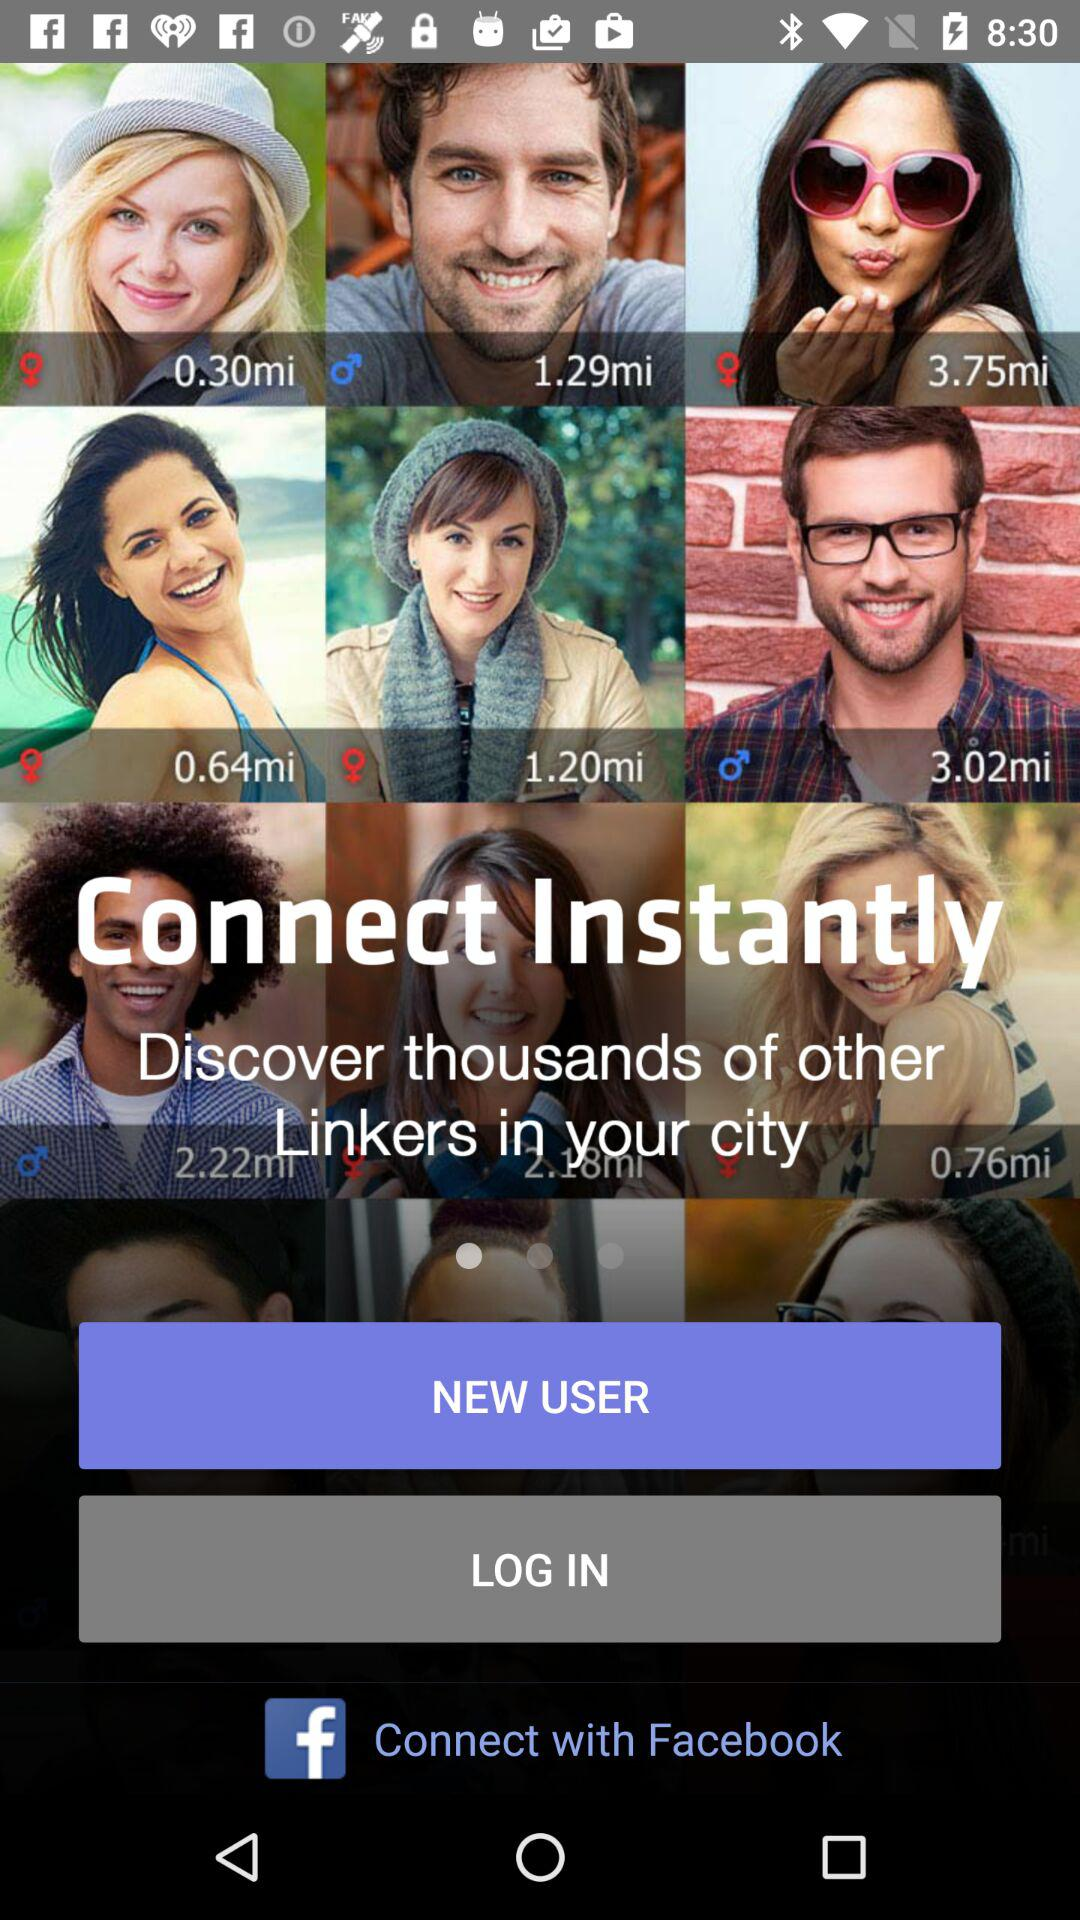What applications can the user use to connect with? The user can connect with "Facebook". 